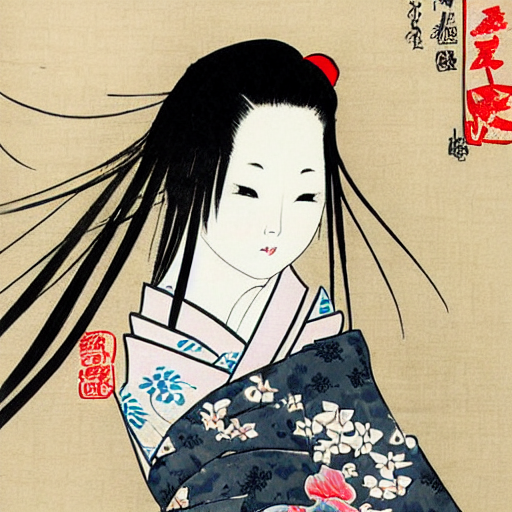Can you explain the cultural significance of this style of art? Certainly! This ukiyo-e style of art holds significant cultural weight in Japan's artistic history. Originating during the Edo period, it translates to 'pictures of the floating world' and represents a genre that aimed to capture fleeting pleasures and the urban lifestyle of Tokyo, then known as Edo. This particular piece highlights the world of Kabuki theatre, which was a popular form of entertainment. The images often depicted beautiful nature scenes, daily life, and celebrated actors like the one here. They were accessible to the common person, in contrast to earlier art forms that were typically commissioned by nobility. 